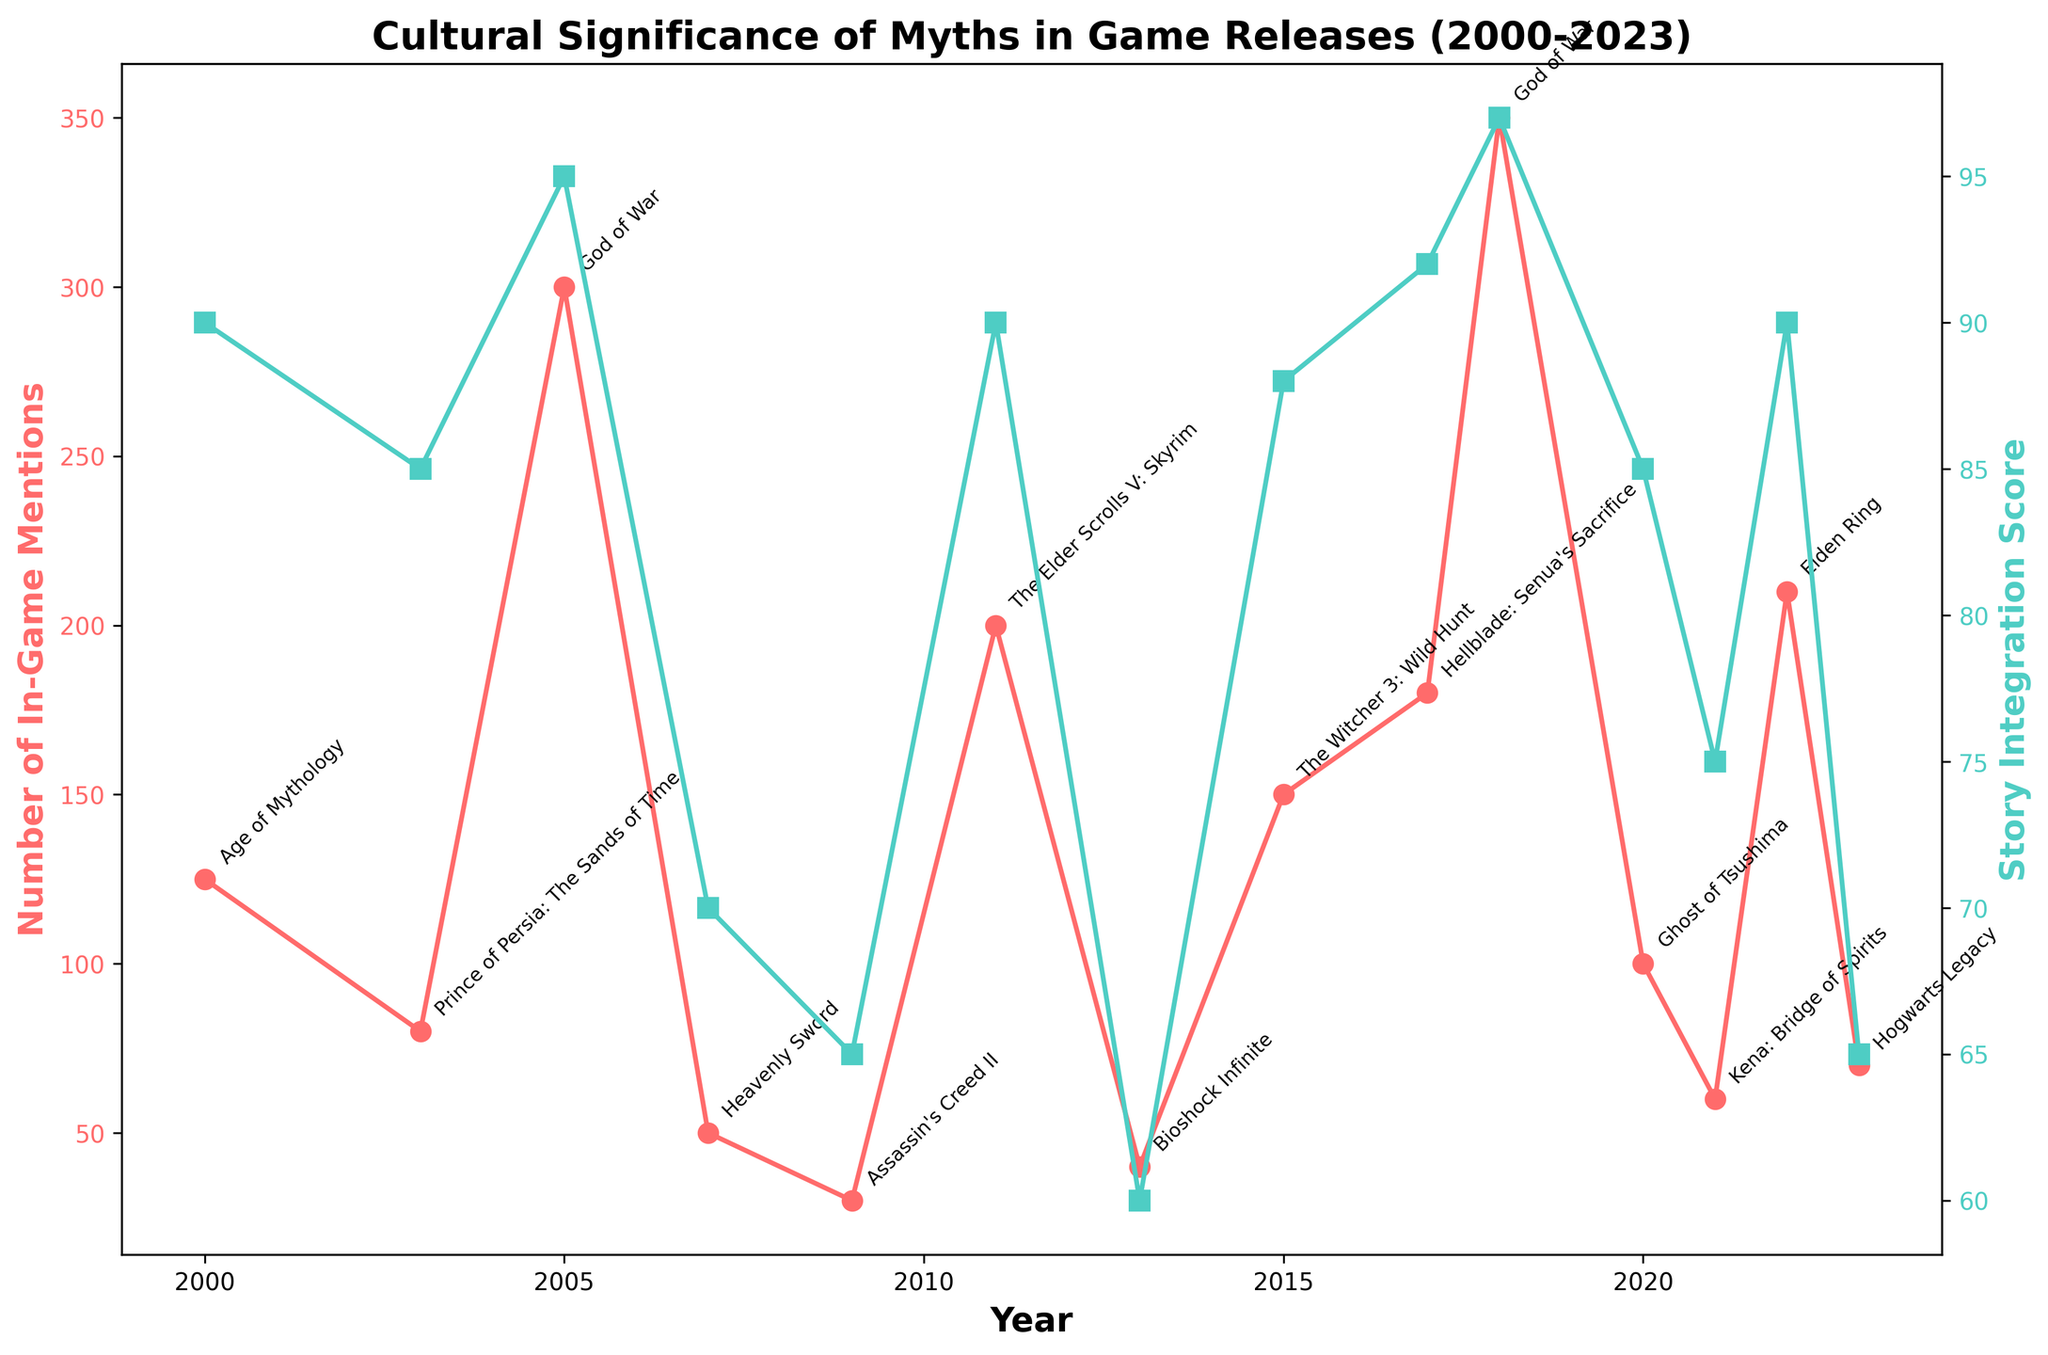What is the title of the plot? The title is text displayed at the top of the plot. It serves to provide a brief description of what the plot represents. In this case, the title indicates that the plot shows the cultural significance of myths in game releases from 2000 to 2023.
Answer: Cultural Significance of Myths in Game Releases (2000-2023) Which myth was referenced the most in 2022 based on in-game mentions? From the plot, look at the year 2022 on the x-axis and identify the data point associated with the most references. The annotation will indicate which myth was referenced in that game.
Answer: Norse Mythology How does the number of in-game mentions in 2005 compare to 2000? Locate the points for the years 2000 and 2005 on the plot and compare the y-values for in-game mentions. The 2005 point is higher, indicating more mentions.
Answer: Higher in 2005 Which game in 2018 had the most integrated myth in its story? Check the year 2018 on the x-axis and look at the data points indicating story integration scores. The annotations tell us the game titles, and we can determine which myth was heavily integrated based on the highest score.
Answer: God of War What is the color of the line representing Number of In-Game Mentions? The plot uses different colors to distinguish between the two y-variables. The color for in-game mentions is described directly in the plot.
Answer: Red What is the average story integration score for games released in 2017 and 2022? To find the average, first identify the story integration scores for both years - 92 for 2017 and 90 for 2022. Sum these values and divide by 2. (92 + 90) / 2 = 91
Answer: 91 Which year shows the highest number of in-game mentions combined with a high story integration score? The plot points with both high mentions and high integration scores will stand out visually. Identify the highest point on the mentions axis and confirm its corresponding integration score.
Answer: 2018 Compare the cultural significance in terms of story integration score between Norse Mythology in 2011 and 2017. Look at the story integration score points for 2011 and 2017, focusing on Norse Mythology. In 2011, it's 90 and in 2017, it's 92.
Answer: Higher in 2017 Which game features British folklore and what is its story integration score in 2023? Locate the point for 2023 and check the annotation to determine the game title and look at the corresponding story integration score.
Answer: Hogwarts Legacy, 65 How did the number of in-game mentions for Japanese Folklore change between 2000 and 2020? Identify games referencing Japanese folklore in these years. Compare the number of in-game mentions (0 in 2000 as not present and 100 in 2020).
Answer: Increased to 100 